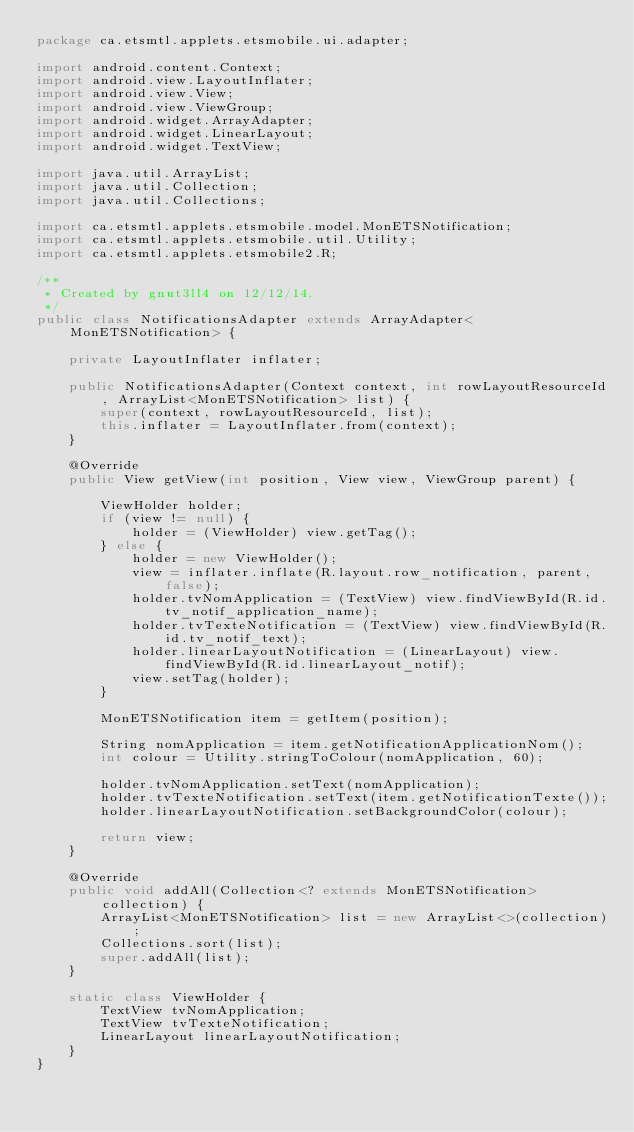<code> <loc_0><loc_0><loc_500><loc_500><_Java_>package ca.etsmtl.applets.etsmobile.ui.adapter;

import android.content.Context;
import android.view.LayoutInflater;
import android.view.View;
import android.view.ViewGroup;
import android.widget.ArrayAdapter;
import android.widget.LinearLayout;
import android.widget.TextView;

import java.util.ArrayList;
import java.util.Collection;
import java.util.Collections;

import ca.etsmtl.applets.etsmobile.model.MonETSNotification;
import ca.etsmtl.applets.etsmobile.util.Utility;
import ca.etsmtl.applets.etsmobile2.R;

/**
 * Created by gnut3ll4 on 12/12/14.
 */
public class NotificationsAdapter extends ArrayAdapter<MonETSNotification> {

    private LayoutInflater inflater;

    public NotificationsAdapter(Context context, int rowLayoutResourceId, ArrayList<MonETSNotification> list) {
        super(context, rowLayoutResourceId, list);
        this.inflater = LayoutInflater.from(context);
    }

    @Override
    public View getView(int position, View view, ViewGroup parent) {

        ViewHolder holder;
        if (view != null) {
            holder = (ViewHolder) view.getTag();
        } else {
            holder = new ViewHolder();
            view = inflater.inflate(R.layout.row_notification, parent, false);
            holder.tvNomApplication = (TextView) view.findViewById(R.id.tv_notif_application_name);
            holder.tvTexteNotification = (TextView) view.findViewById(R.id.tv_notif_text);
            holder.linearLayoutNotification = (LinearLayout) view.findViewById(R.id.linearLayout_notif);
            view.setTag(holder);
        }

        MonETSNotification item = getItem(position);

        String nomApplication = item.getNotificationApplicationNom();
        int colour = Utility.stringToColour(nomApplication, 60);

        holder.tvNomApplication.setText(nomApplication);
        holder.tvTexteNotification.setText(item.getNotificationTexte());
        holder.linearLayoutNotification.setBackgroundColor(colour);

        return view;
    }

    @Override
    public void addAll(Collection<? extends MonETSNotification> collection) {
        ArrayList<MonETSNotification> list = new ArrayList<>(collection);
        Collections.sort(list);
        super.addAll(list);
    }

    static class ViewHolder {
        TextView tvNomApplication;
        TextView tvTexteNotification;
        LinearLayout linearLayoutNotification;
    }
}</code> 